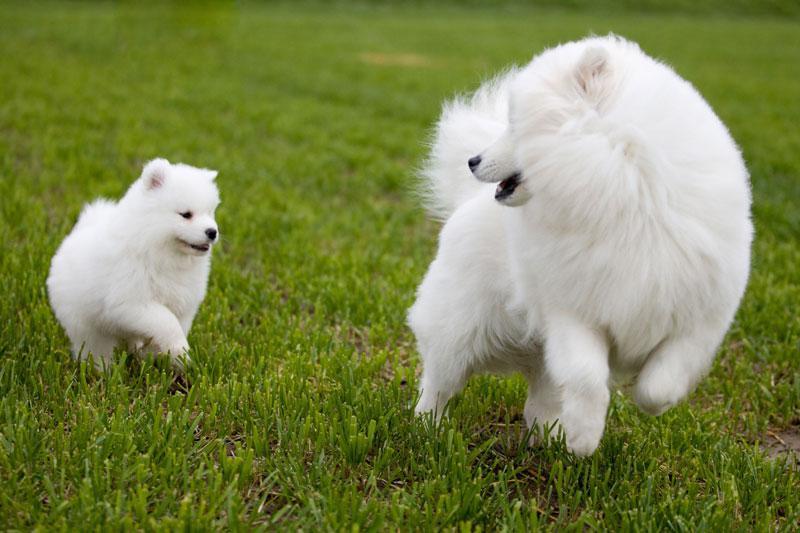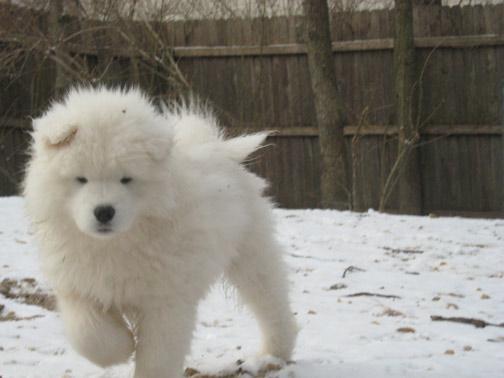The first image is the image on the left, the second image is the image on the right. Examine the images to the left and right. Is the description "One of the images shows an adult dog with a puppy on the grass." accurate? Answer yes or no. Yes. The first image is the image on the left, the second image is the image on the right. Examine the images to the left and right. Is the description "One image shows a small white pup next to a big white dog on green grass, and the other image contains exactly one white pup on a white surface." accurate? Answer yes or no. Yes. 